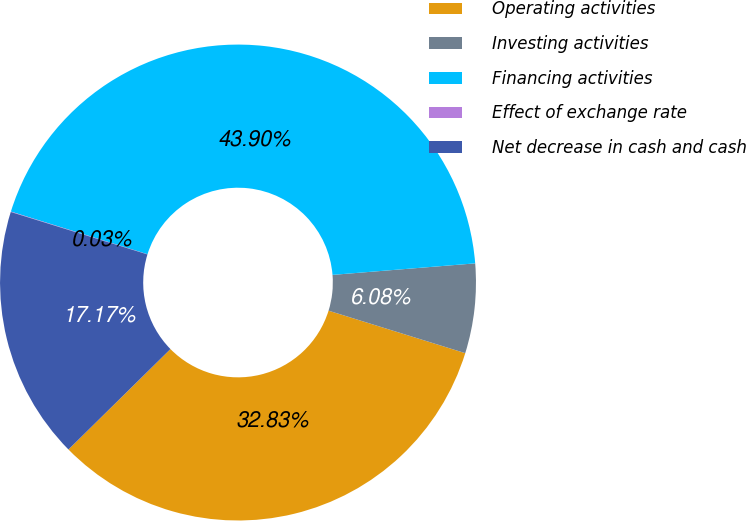Convert chart. <chart><loc_0><loc_0><loc_500><loc_500><pie_chart><fcel>Operating activities<fcel>Investing activities<fcel>Financing activities<fcel>Effect of exchange rate<fcel>Net decrease in cash and cash<nl><fcel>32.83%<fcel>6.08%<fcel>43.9%<fcel>0.03%<fcel>17.17%<nl></chart> 